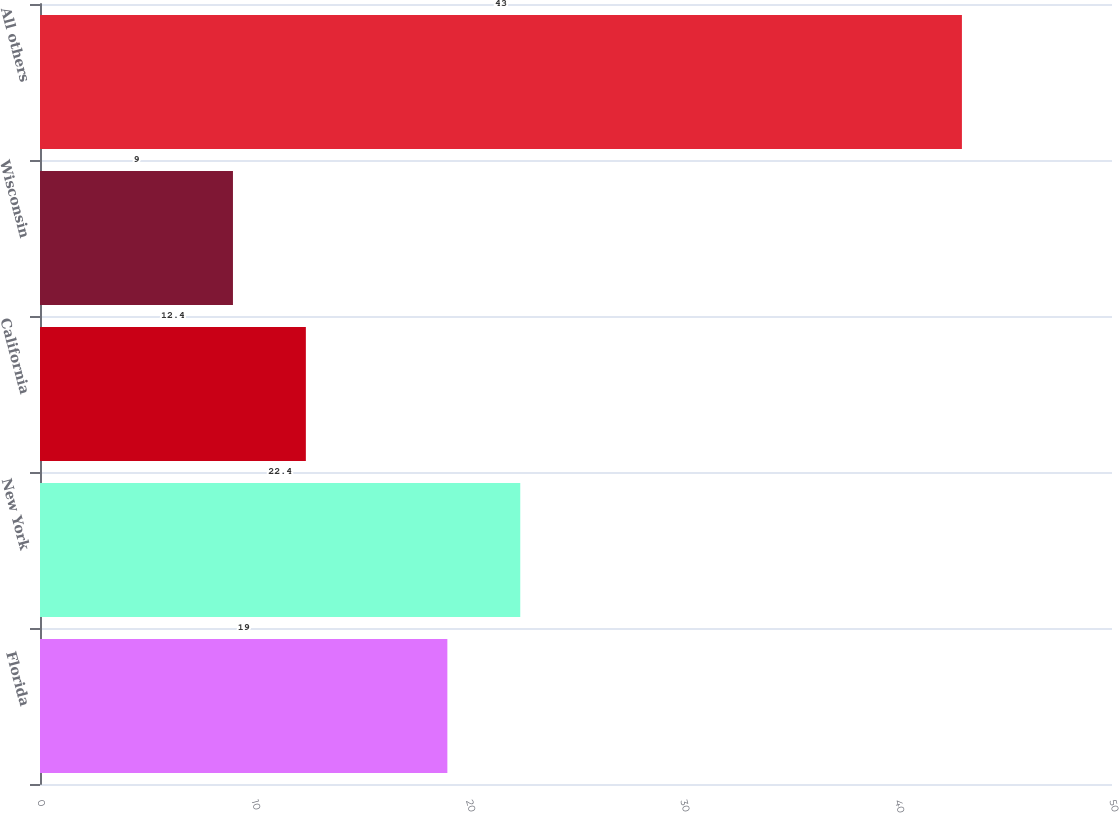Convert chart. <chart><loc_0><loc_0><loc_500><loc_500><bar_chart><fcel>Florida<fcel>New York<fcel>California<fcel>Wisconsin<fcel>All others<nl><fcel>19<fcel>22.4<fcel>12.4<fcel>9<fcel>43<nl></chart> 